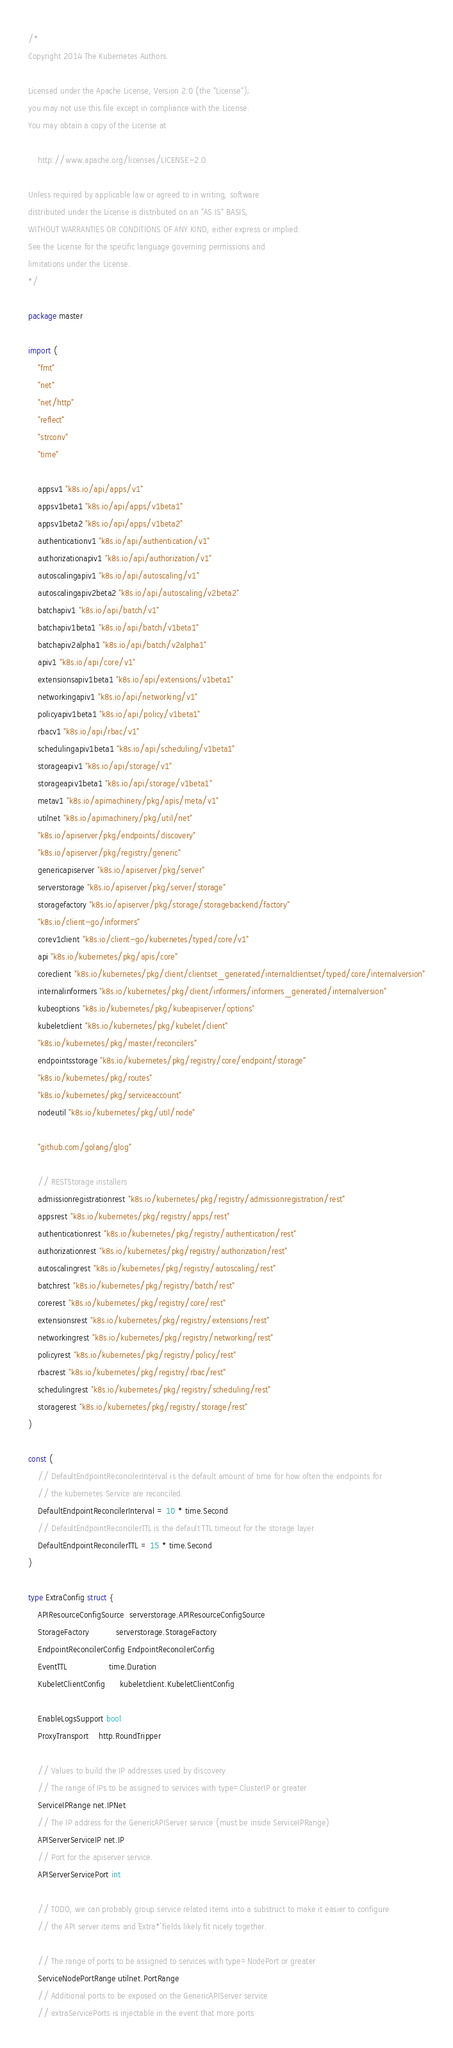<code> <loc_0><loc_0><loc_500><loc_500><_Go_>/*
Copyright 2014 The Kubernetes Authors.

Licensed under the Apache License, Version 2.0 (the "License");
you may not use this file except in compliance with the License.
You may obtain a copy of the License at

    http://www.apache.org/licenses/LICENSE-2.0

Unless required by applicable law or agreed to in writing, software
distributed under the License is distributed on an "AS IS" BASIS,
WITHOUT WARRANTIES OR CONDITIONS OF ANY KIND, either express or implied.
See the License for the specific language governing permissions and
limitations under the License.
*/

package master

import (
	"fmt"
	"net"
	"net/http"
	"reflect"
	"strconv"
	"time"

	appsv1 "k8s.io/api/apps/v1"
	appsv1beta1 "k8s.io/api/apps/v1beta1"
	appsv1beta2 "k8s.io/api/apps/v1beta2"
	authenticationv1 "k8s.io/api/authentication/v1"
	authorizationapiv1 "k8s.io/api/authorization/v1"
	autoscalingapiv1 "k8s.io/api/autoscaling/v1"
	autoscalingapiv2beta2 "k8s.io/api/autoscaling/v2beta2"
	batchapiv1 "k8s.io/api/batch/v1"
	batchapiv1beta1 "k8s.io/api/batch/v1beta1"
	batchapiv2alpha1 "k8s.io/api/batch/v2alpha1"
	apiv1 "k8s.io/api/core/v1"
	extensionsapiv1beta1 "k8s.io/api/extensions/v1beta1"
	networkingapiv1 "k8s.io/api/networking/v1"
	policyapiv1beta1 "k8s.io/api/policy/v1beta1"
	rbacv1 "k8s.io/api/rbac/v1"
	schedulingapiv1beta1 "k8s.io/api/scheduling/v1beta1"
	storageapiv1 "k8s.io/api/storage/v1"
	storageapiv1beta1 "k8s.io/api/storage/v1beta1"
	metav1 "k8s.io/apimachinery/pkg/apis/meta/v1"
	utilnet "k8s.io/apimachinery/pkg/util/net"
	"k8s.io/apiserver/pkg/endpoints/discovery"
	"k8s.io/apiserver/pkg/registry/generic"
	genericapiserver "k8s.io/apiserver/pkg/server"
	serverstorage "k8s.io/apiserver/pkg/server/storage"
	storagefactory "k8s.io/apiserver/pkg/storage/storagebackend/factory"
	"k8s.io/client-go/informers"
	corev1client "k8s.io/client-go/kubernetes/typed/core/v1"
	api "k8s.io/kubernetes/pkg/apis/core"
	coreclient "k8s.io/kubernetes/pkg/client/clientset_generated/internalclientset/typed/core/internalversion"
	internalinformers "k8s.io/kubernetes/pkg/client/informers/informers_generated/internalversion"
	kubeoptions "k8s.io/kubernetes/pkg/kubeapiserver/options"
	kubeletclient "k8s.io/kubernetes/pkg/kubelet/client"
	"k8s.io/kubernetes/pkg/master/reconcilers"
	endpointsstorage "k8s.io/kubernetes/pkg/registry/core/endpoint/storage"
	"k8s.io/kubernetes/pkg/routes"
	"k8s.io/kubernetes/pkg/serviceaccount"
	nodeutil "k8s.io/kubernetes/pkg/util/node"

	"github.com/golang/glog"

	// RESTStorage installers
	admissionregistrationrest "k8s.io/kubernetes/pkg/registry/admissionregistration/rest"
	appsrest "k8s.io/kubernetes/pkg/registry/apps/rest"
	authenticationrest "k8s.io/kubernetes/pkg/registry/authentication/rest"
	authorizationrest "k8s.io/kubernetes/pkg/registry/authorization/rest"
	autoscalingrest "k8s.io/kubernetes/pkg/registry/autoscaling/rest"
	batchrest "k8s.io/kubernetes/pkg/registry/batch/rest"
	corerest "k8s.io/kubernetes/pkg/registry/core/rest"
	extensionsrest "k8s.io/kubernetes/pkg/registry/extensions/rest"
	networkingrest "k8s.io/kubernetes/pkg/registry/networking/rest"
	policyrest "k8s.io/kubernetes/pkg/registry/policy/rest"
	rbacrest "k8s.io/kubernetes/pkg/registry/rbac/rest"
	schedulingrest "k8s.io/kubernetes/pkg/registry/scheduling/rest"
	storagerest "k8s.io/kubernetes/pkg/registry/storage/rest"
)

const (
	// DefaultEndpointReconcilerInterval is the default amount of time for how often the endpoints for
	// the kubernetes Service are reconciled.
	DefaultEndpointReconcilerInterval = 10 * time.Second
	// DefaultEndpointReconcilerTTL is the default TTL timeout for the storage layer
	DefaultEndpointReconcilerTTL = 15 * time.Second
)

type ExtraConfig struct {
	APIResourceConfigSource  serverstorage.APIResourceConfigSource
	StorageFactory           serverstorage.StorageFactory
	EndpointReconcilerConfig EndpointReconcilerConfig
	EventTTL                 time.Duration
	KubeletClientConfig      kubeletclient.KubeletClientConfig

	EnableLogsSupport bool
	ProxyTransport    http.RoundTripper

	// Values to build the IP addresses used by discovery
	// The range of IPs to be assigned to services with type=ClusterIP or greater
	ServiceIPRange net.IPNet
	// The IP address for the GenericAPIServer service (must be inside ServiceIPRange)
	APIServerServiceIP net.IP
	// Port for the apiserver service.
	APIServerServicePort int

	// TODO, we can probably group service related items into a substruct to make it easier to configure
	// the API server items and `Extra*` fields likely fit nicely together.

	// The range of ports to be assigned to services with type=NodePort or greater
	ServiceNodePortRange utilnet.PortRange
	// Additional ports to be exposed on the GenericAPIServer service
	// extraServicePorts is injectable in the event that more ports</code> 